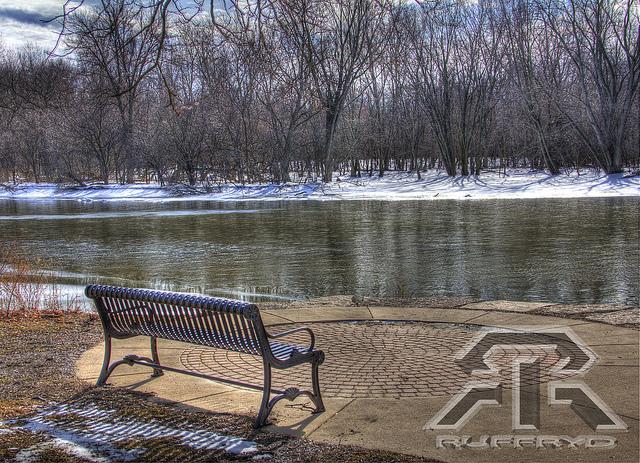What is the weather like?
Write a very short answer. Cold. Is this a nice bench?
Concise answer only. Yes. What is on the ground on the other side of the water?
Give a very brief answer. Snow. 